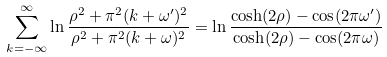<formula> <loc_0><loc_0><loc_500><loc_500>\sum _ { k = - \infty } ^ { \infty } \ln \frac { \rho ^ { 2 } + \pi ^ { 2 } ( k + \omega ^ { \prime } ) ^ { 2 } } { \rho ^ { 2 } + \pi ^ { 2 } ( k + \omega ) ^ { 2 } } = \ln \frac { \cosh ( 2 \rho ) - \cos ( 2 \pi \omega ^ { \prime } ) } { \cosh ( 2 \rho ) - \cos ( 2 \pi \omega ) }</formula> 